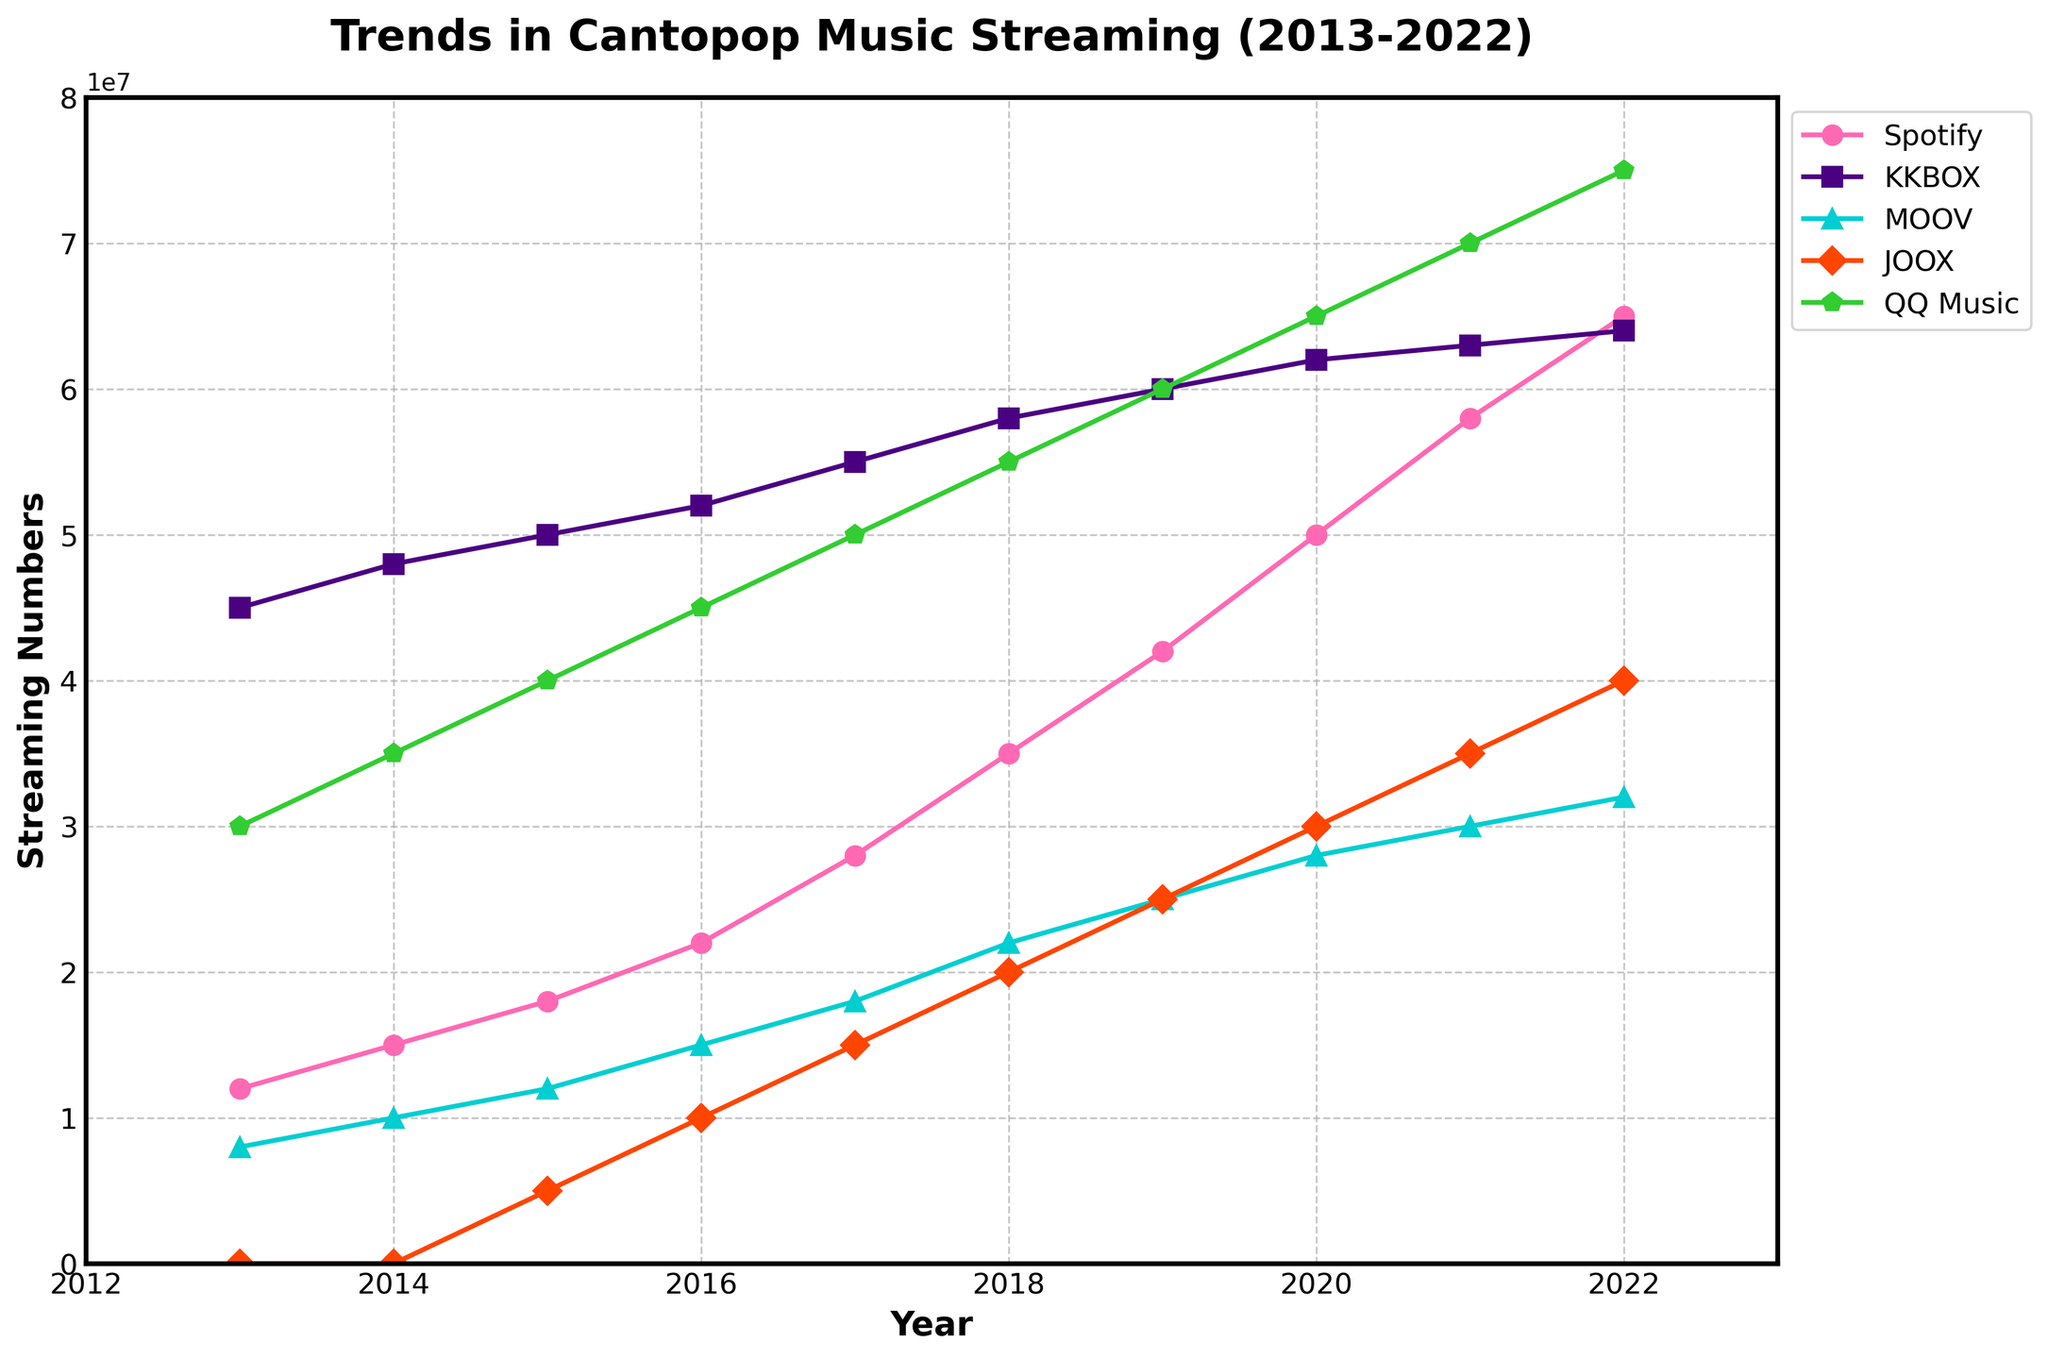What year did Spotify reach 50 million streaming numbers? Locate the 'Spotify' line on the plot. Find the point where it intersects with the 50 million streaming numbers mark on the y-axis. Read the corresponding year on the x-axis.
Answer: 2020 Which platform had the highest streaming numbers in 2022? Look at the end of each line to find the values for 2022. Compare these values to determine the highest.
Answer: QQ Music Between which years did MOOV see the most significant increase in streaming numbers? Identify the steepest slope on the 'MOOV' line by comparing the changes in streaming numbers between consecutive years.
Answer: 2016-2017 Comparing 2020, which platform had the second highest streaming numbers? Identify the streaming numbers of each platform in 2020 and find the second highest value.
Answer: Spotify How many times did Spotify's streaming numbers double from 2013 to 2022? Identify the streaming numbers for Spotify in 2013 and check if and when they doubled by following the line. Spotify's 2013 number is 12000000. Double of it is 24000000. Check how many times Spotify reached values ≥ 24000000.
Answer: 2 Which platform shows the least fluctuation in streaming numbers over the decade? Compare the overall curves of each platform, focusing on the amplitude of their changes.
Answer: KKBOX How do the streaming numbers for MOOV in 2019 compare visually to JOOX in the same year? Compare the y-values of the points on the 'MOOV' and 'JOOX' lines for 2019.
Answer: MOOV numbers are slightly higher than JOOX in 2019 